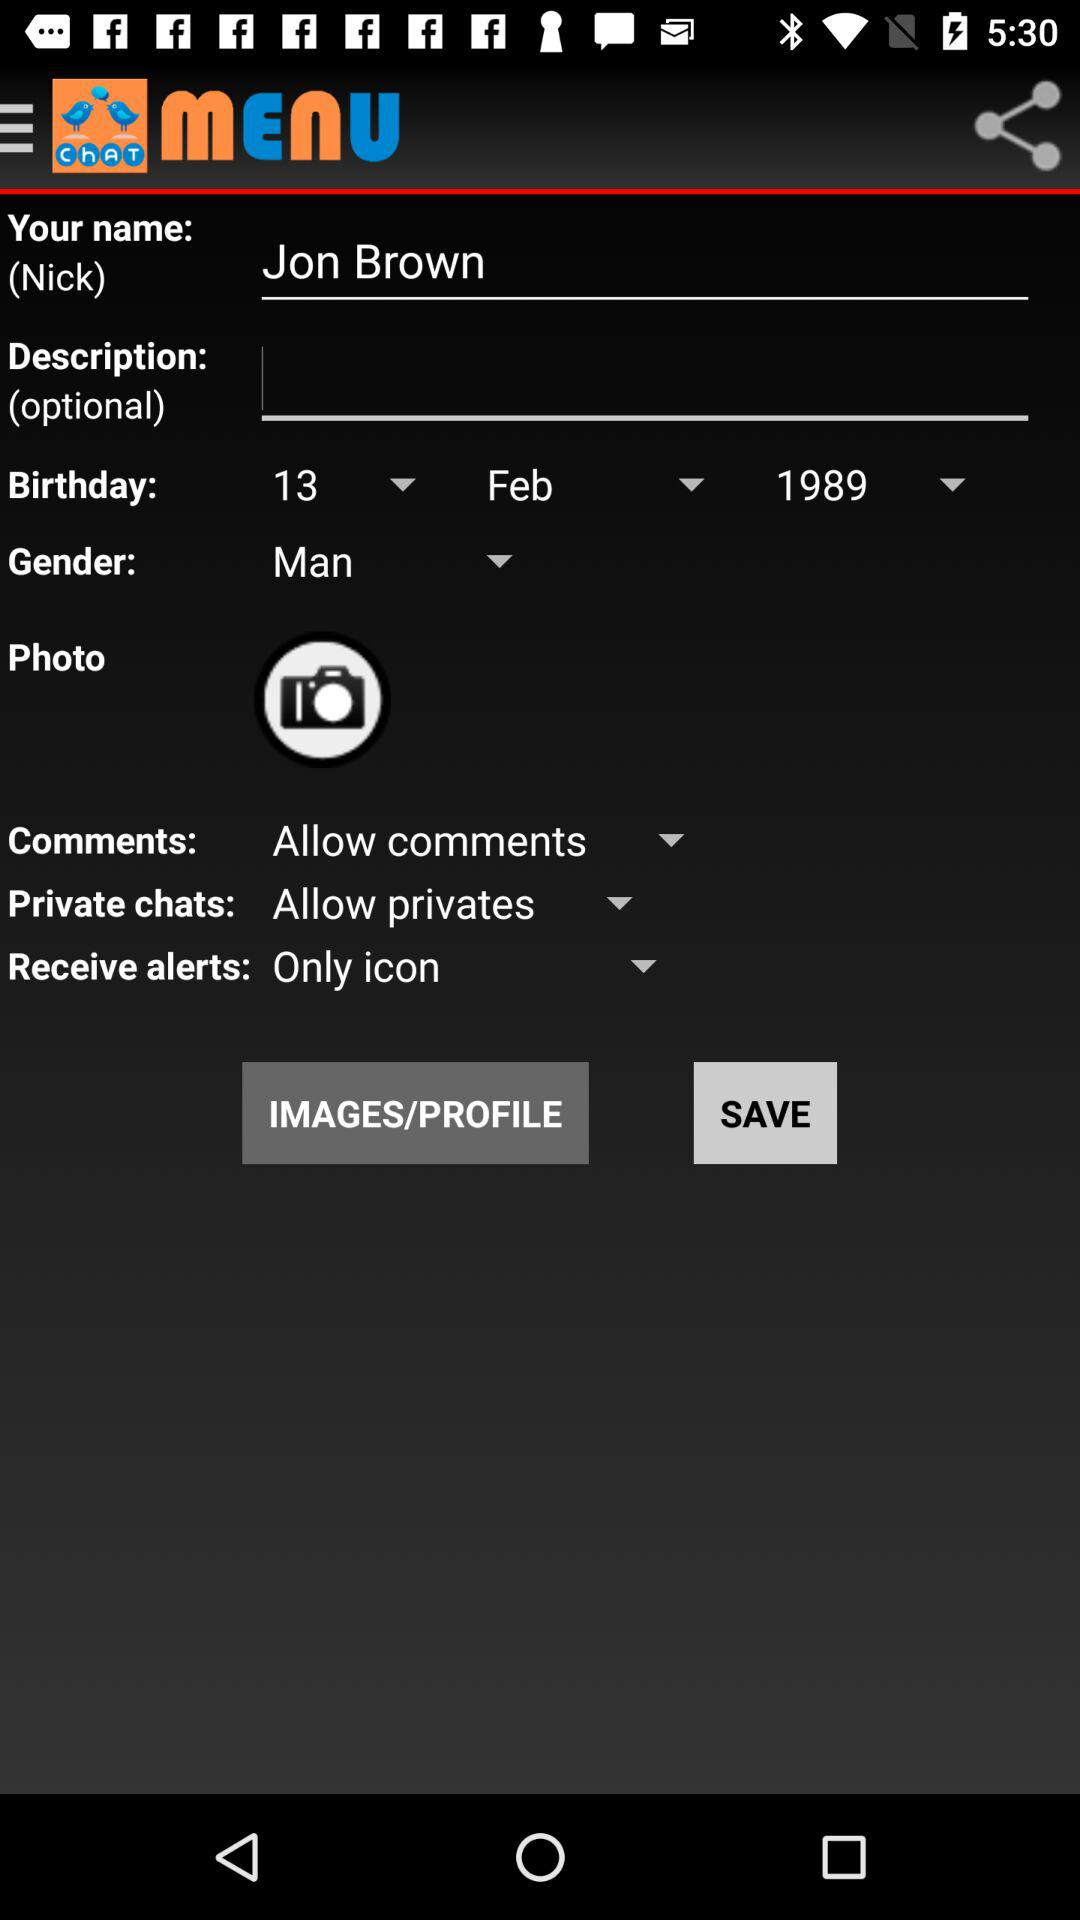What is selected in "Receive alerts"? In "Receive alerts", "Only icon" is selected. 